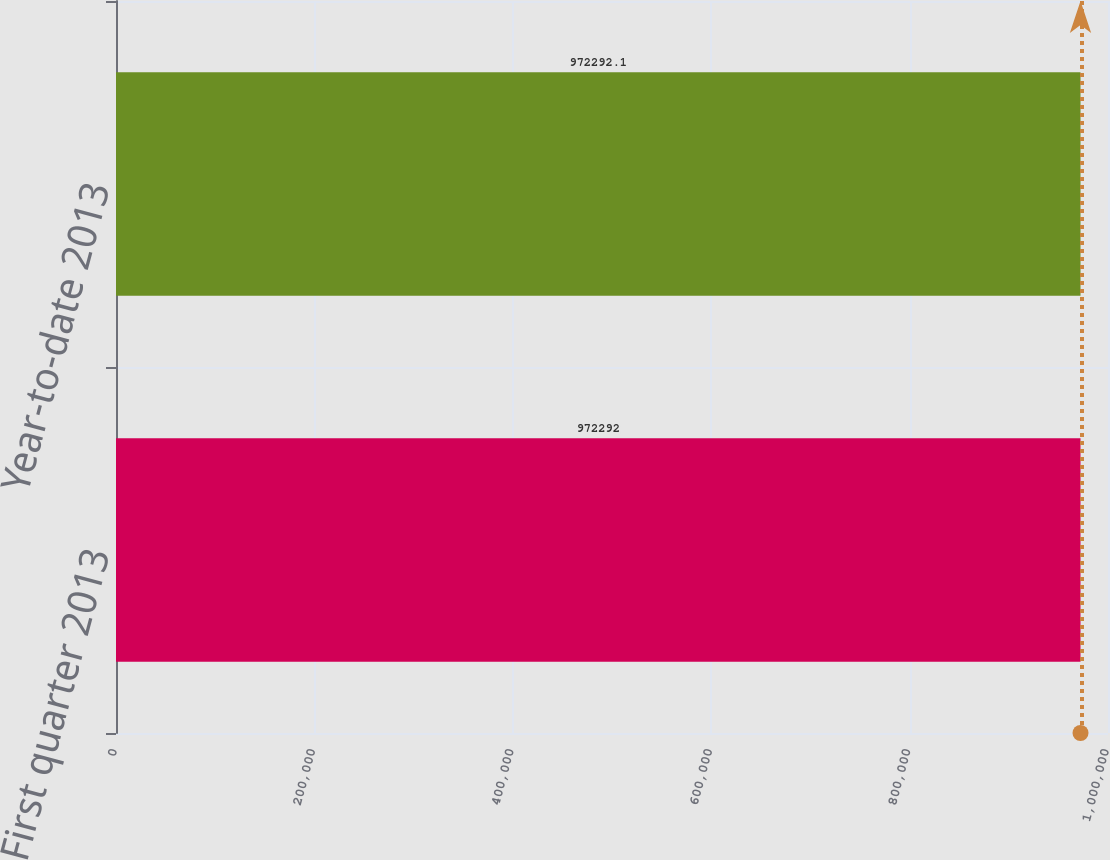Convert chart. <chart><loc_0><loc_0><loc_500><loc_500><bar_chart><fcel>First quarter 2013<fcel>Year-to-date 2013<nl><fcel>972292<fcel>972292<nl></chart> 